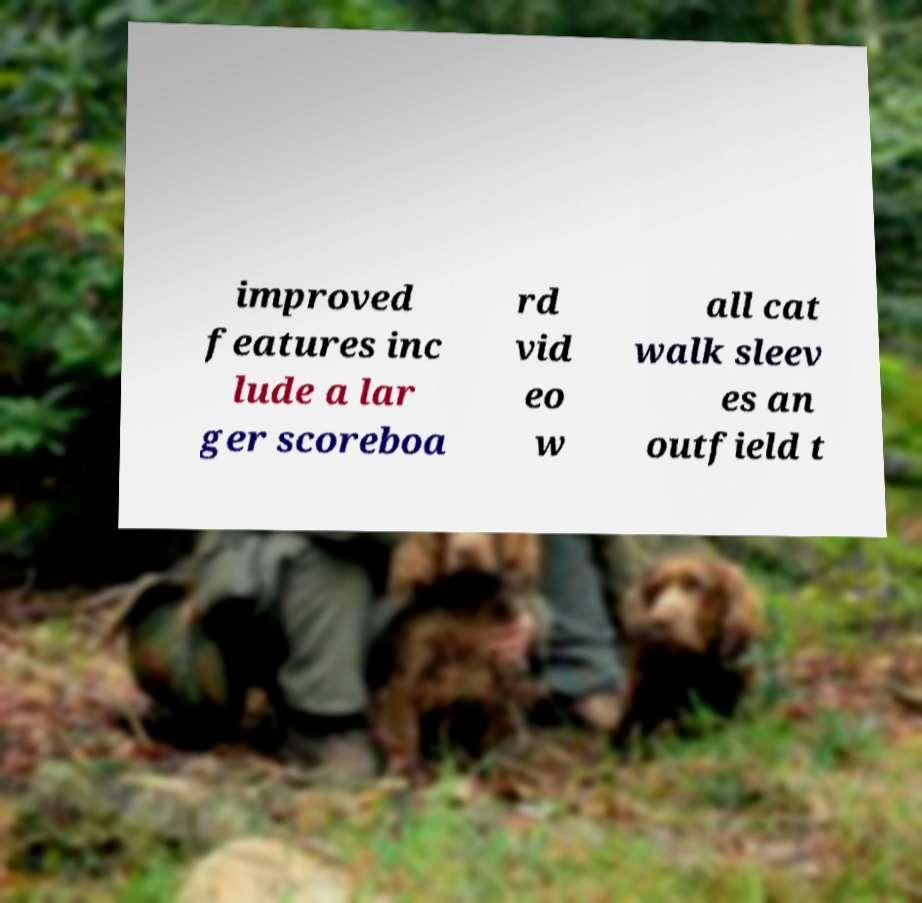What messages or text are displayed in this image? I need them in a readable, typed format. improved features inc lude a lar ger scoreboa rd vid eo w all cat walk sleev es an outfield t 